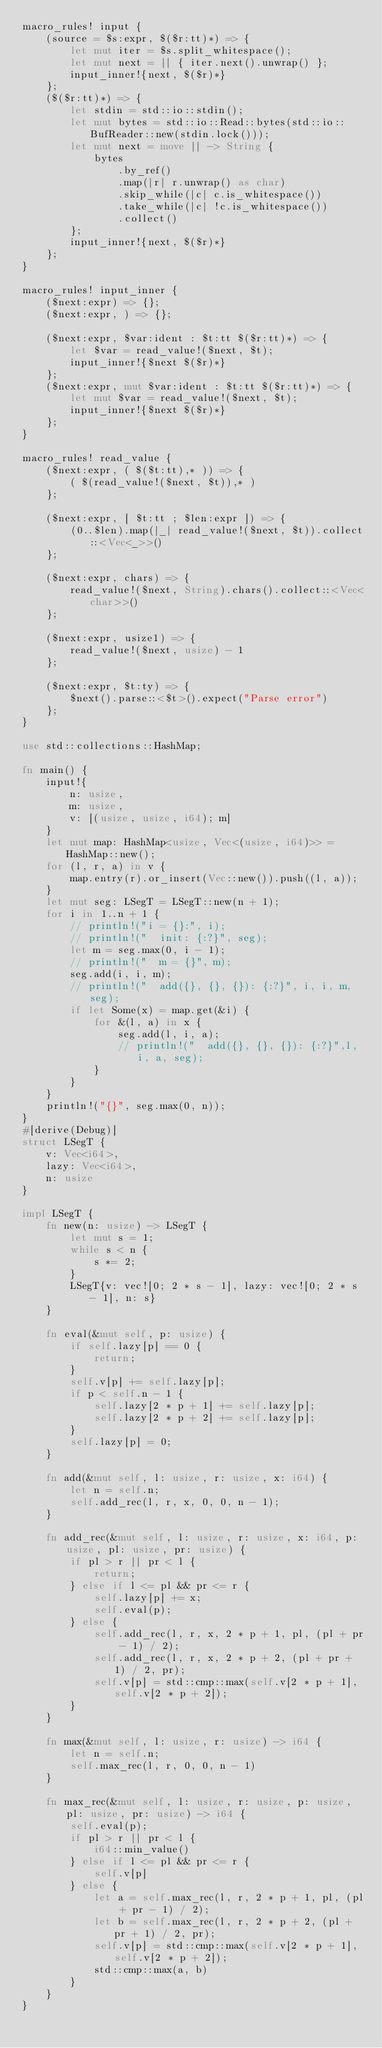<code> <loc_0><loc_0><loc_500><loc_500><_Rust_>macro_rules! input {
    (source = $s:expr, $($r:tt)*) => {
        let mut iter = $s.split_whitespace();
        let mut next = || { iter.next().unwrap() };
        input_inner!{next, $($r)*}
    };
    ($($r:tt)*) => {
        let stdin = std::io::stdin();
        let mut bytes = std::io::Read::bytes(std::io::BufReader::new(stdin.lock()));
        let mut next = move || -> String {
            bytes
                .by_ref()
                .map(|r| r.unwrap() as char)
                .skip_while(|c| c.is_whitespace())
                .take_while(|c| !c.is_whitespace())
                .collect()
        };
        input_inner!{next, $($r)*}
    };
}

macro_rules! input_inner {
    ($next:expr) => {};
    ($next:expr, ) => {};

    ($next:expr, $var:ident : $t:tt $($r:tt)*) => {
        let $var = read_value!($next, $t);
        input_inner!{$next $($r)*}
    };
    ($next:expr, mut $var:ident : $t:tt $($r:tt)*) => {
        let mut $var = read_value!($next, $t);
        input_inner!{$next $($r)*}
    };
}

macro_rules! read_value {
    ($next:expr, ( $($t:tt),* )) => {
        ( $(read_value!($next, $t)),* )
    };

    ($next:expr, [ $t:tt ; $len:expr ]) => {
        (0..$len).map(|_| read_value!($next, $t)).collect::<Vec<_>>()
    };

    ($next:expr, chars) => {
        read_value!($next, String).chars().collect::<Vec<char>>()
    };

    ($next:expr, usize1) => {
        read_value!($next, usize) - 1
    };

    ($next:expr, $t:ty) => {
        $next().parse::<$t>().expect("Parse error")
    };
}

use std::collections::HashMap;

fn main() {
    input!{
        n: usize,
        m: usize,
        v: [(usize, usize, i64); m]
    }
    let mut map: HashMap<usize, Vec<(usize, i64)>> = HashMap::new();
    for (l, r, a) in v {
        map.entry(r).or_insert(Vec::new()).push((l, a));
    }
    let mut seg: LSegT = LSegT::new(n + 1);
    for i in 1..n + 1 {
        // println!("i = {}:", i);
        // println!("  init: {:?}", seg);
        let m = seg.max(0, i - 1);
        // println!("  m = {}", m);
        seg.add(i, i, m);
        // println!("  add({}, {}, {}): {:?}", i, i, m, seg);
        if let Some(x) = map.get(&i) {
            for &(l, a) in x {
                seg.add(l, i, a);
                // println!("  add({}, {}, {}): {:?}",l, i, a, seg);
            }
        }
    }
    println!("{}", seg.max(0, n));
}
#[derive(Debug)]
struct LSegT {
    v: Vec<i64>,
    lazy: Vec<i64>,
    n: usize
}

impl LSegT {
    fn new(n: usize) -> LSegT {
        let mut s = 1;
        while s < n {
            s *= 2;
        }
        LSegT{v: vec![0; 2 * s - 1], lazy: vec![0; 2 * s - 1], n: s}
    }

    fn eval(&mut self, p: usize) {
        if self.lazy[p] == 0 {
            return;
        }
        self.v[p] += self.lazy[p];
        if p < self.n - 1 {
            self.lazy[2 * p + 1] += self.lazy[p];
            self.lazy[2 * p + 2] += self.lazy[p];
        }
        self.lazy[p] = 0;
    }

    fn add(&mut self, l: usize, r: usize, x: i64) {
        let n = self.n;
        self.add_rec(l, r, x, 0, 0, n - 1);
    }

    fn add_rec(&mut self, l: usize, r: usize, x: i64, p: usize, pl: usize, pr: usize) {
        if pl > r || pr < l {
            return;
        } else if l <= pl && pr <= r {
            self.lazy[p] += x;
            self.eval(p);
        } else {
            self.add_rec(l, r, x, 2 * p + 1, pl, (pl + pr - 1) / 2);
            self.add_rec(l, r, x, 2 * p + 2, (pl + pr + 1) / 2, pr);
            self.v[p] = std::cmp::max(self.v[2 * p + 1], self.v[2 * p + 2]);
        }
    }

    fn max(&mut self, l: usize, r: usize) -> i64 {
        let n = self.n;
        self.max_rec(l, r, 0, 0, n - 1)
    }

    fn max_rec(&mut self, l: usize, r: usize, p: usize, pl: usize, pr: usize) -> i64 {
        self.eval(p);
        if pl > r || pr < l {
            i64::min_value()
        } else if l <= pl && pr <= r {
            self.v[p]
        } else {
            let a = self.max_rec(l, r, 2 * p + 1, pl, (pl + pr - 1) / 2);
            let b = self.max_rec(l, r, 2 * p + 2, (pl + pr + 1) / 2, pr);
            self.v[p] = std::cmp::max(self.v[2 * p + 1], self.v[2 * p + 2]);
            std::cmp::max(a, b)
        }
    }
}
</code> 